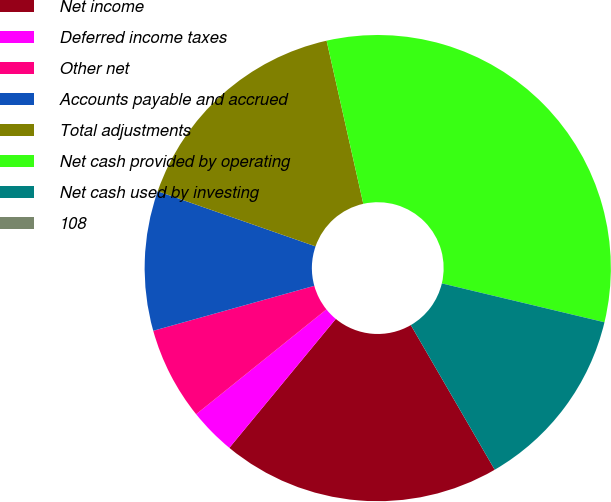Convert chart to OTSL. <chart><loc_0><loc_0><loc_500><loc_500><pie_chart><fcel>Net income<fcel>Deferred income taxes<fcel>Other net<fcel>Accounts payable and accrued<fcel>Total adjustments<fcel>Net cash provided by operating<fcel>Net cash used by investing<fcel>108<nl><fcel>19.35%<fcel>3.23%<fcel>6.45%<fcel>9.68%<fcel>16.13%<fcel>32.25%<fcel>12.9%<fcel>0.0%<nl></chart> 